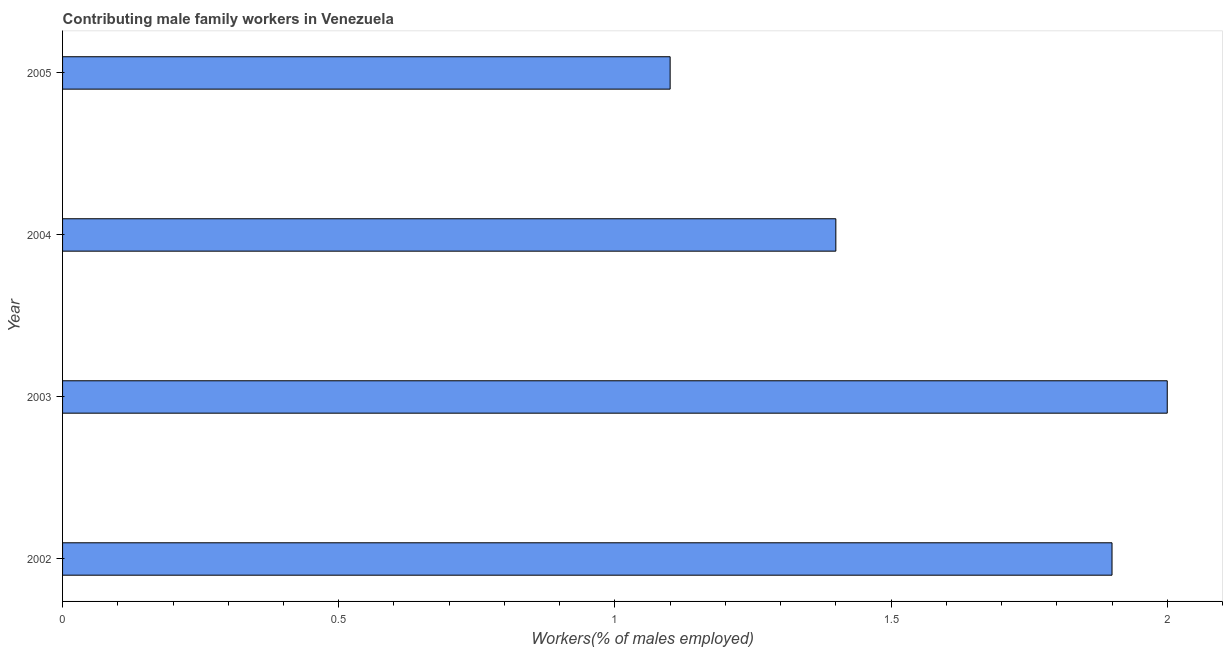Does the graph contain grids?
Your answer should be very brief. No. What is the title of the graph?
Make the answer very short. Contributing male family workers in Venezuela. What is the label or title of the X-axis?
Your answer should be very brief. Workers(% of males employed). What is the contributing male family workers in 2004?
Provide a short and direct response. 1.4. Across all years, what is the maximum contributing male family workers?
Offer a very short reply. 2. Across all years, what is the minimum contributing male family workers?
Your answer should be very brief. 1.1. In which year was the contributing male family workers maximum?
Offer a terse response. 2003. What is the sum of the contributing male family workers?
Ensure brevity in your answer.  6.4. What is the average contributing male family workers per year?
Keep it short and to the point. 1.6. What is the median contributing male family workers?
Make the answer very short. 1.65. Do a majority of the years between 2003 and 2005 (inclusive) have contributing male family workers greater than 0.9 %?
Make the answer very short. Yes. What is the ratio of the contributing male family workers in 2003 to that in 2005?
Offer a very short reply. 1.82. Is the contributing male family workers in 2002 less than that in 2005?
Give a very brief answer. No. What is the difference between the highest and the second highest contributing male family workers?
Your response must be concise. 0.1. Is the sum of the contributing male family workers in 2002 and 2004 greater than the maximum contributing male family workers across all years?
Offer a terse response. Yes. What is the difference between the highest and the lowest contributing male family workers?
Keep it short and to the point. 0.9. In how many years, is the contributing male family workers greater than the average contributing male family workers taken over all years?
Ensure brevity in your answer.  2. How many bars are there?
Provide a short and direct response. 4. Are all the bars in the graph horizontal?
Your answer should be very brief. Yes. Are the values on the major ticks of X-axis written in scientific E-notation?
Provide a short and direct response. No. What is the Workers(% of males employed) of 2002?
Offer a very short reply. 1.9. What is the Workers(% of males employed) in 2003?
Your answer should be compact. 2. What is the Workers(% of males employed) in 2004?
Keep it short and to the point. 1.4. What is the Workers(% of males employed) in 2005?
Your answer should be compact. 1.1. What is the difference between the Workers(% of males employed) in 2002 and 2003?
Your answer should be compact. -0.1. What is the difference between the Workers(% of males employed) in 2002 and 2004?
Offer a very short reply. 0.5. What is the difference between the Workers(% of males employed) in 2003 and 2004?
Provide a succinct answer. 0.6. What is the difference between the Workers(% of males employed) in 2003 and 2005?
Make the answer very short. 0.9. What is the difference between the Workers(% of males employed) in 2004 and 2005?
Ensure brevity in your answer.  0.3. What is the ratio of the Workers(% of males employed) in 2002 to that in 2003?
Provide a succinct answer. 0.95. What is the ratio of the Workers(% of males employed) in 2002 to that in 2004?
Provide a short and direct response. 1.36. What is the ratio of the Workers(% of males employed) in 2002 to that in 2005?
Make the answer very short. 1.73. What is the ratio of the Workers(% of males employed) in 2003 to that in 2004?
Your answer should be very brief. 1.43. What is the ratio of the Workers(% of males employed) in 2003 to that in 2005?
Give a very brief answer. 1.82. What is the ratio of the Workers(% of males employed) in 2004 to that in 2005?
Ensure brevity in your answer.  1.27. 